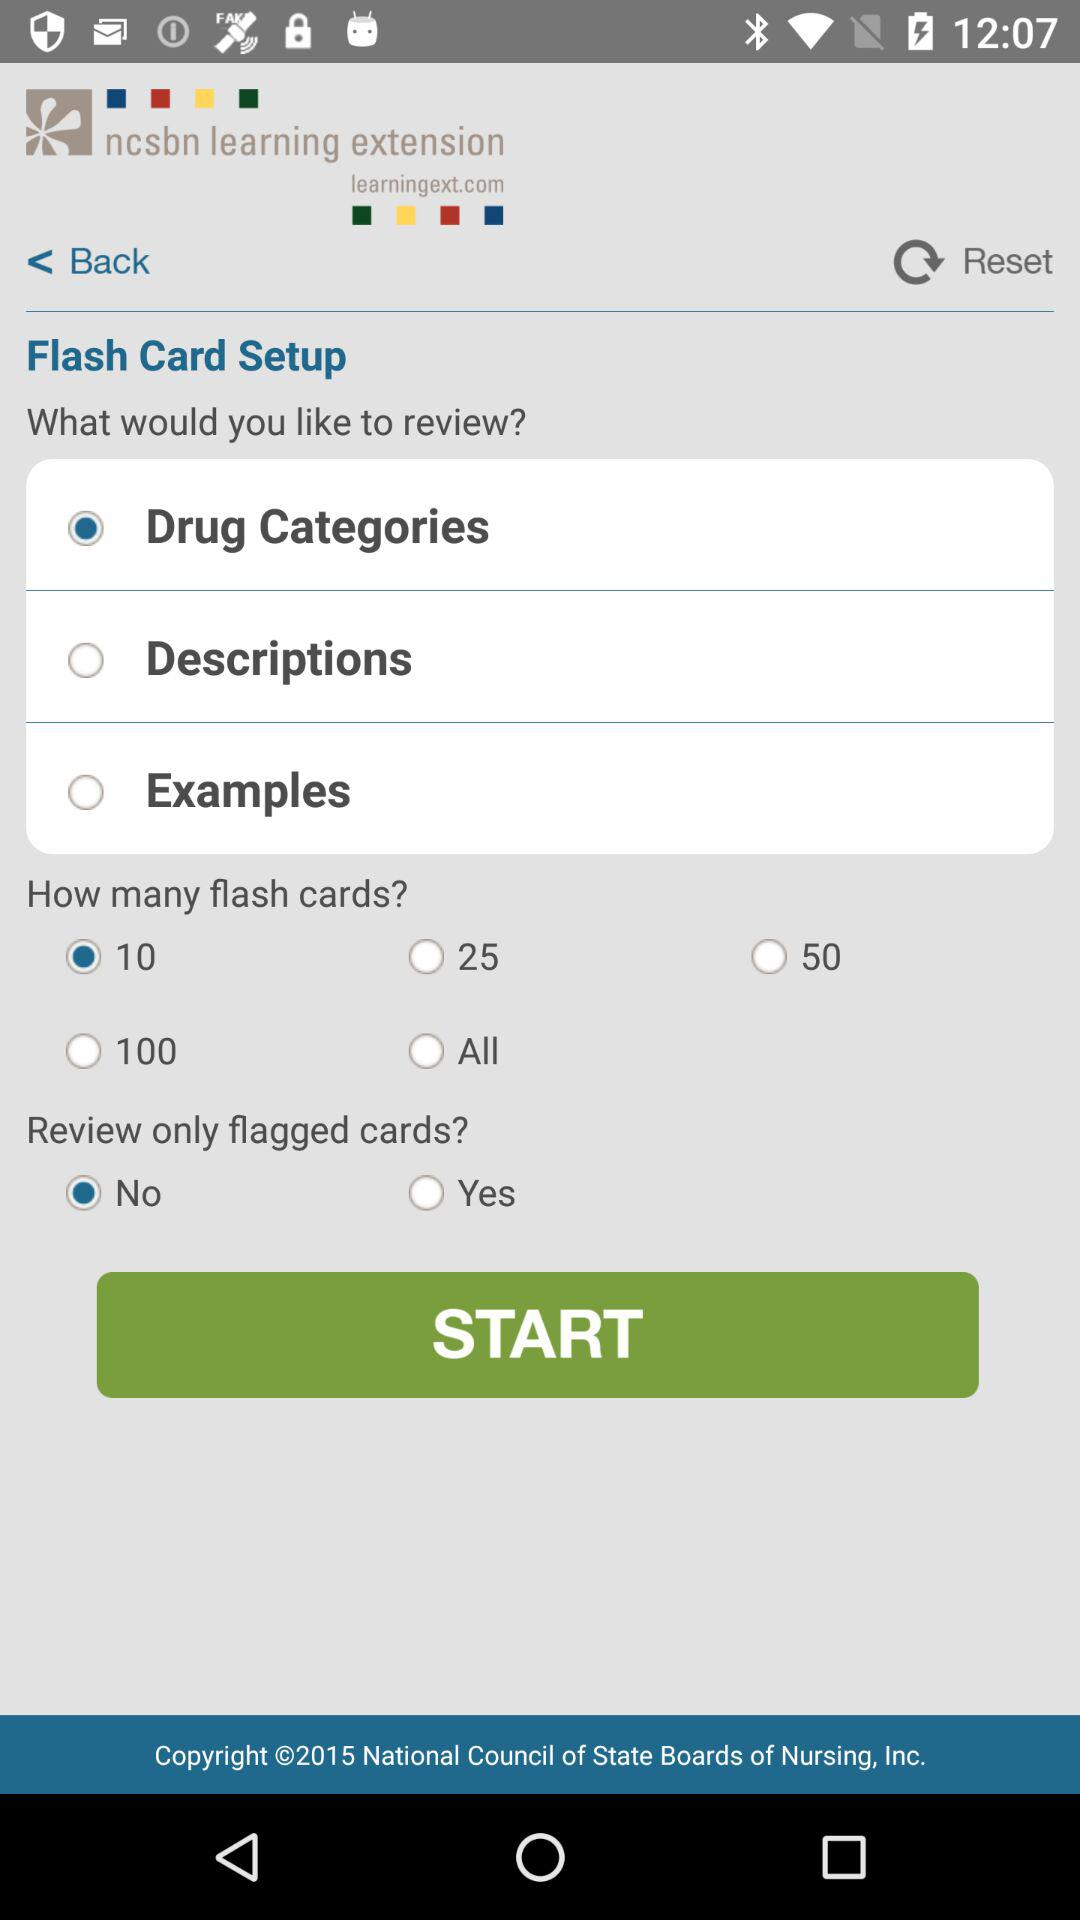What is the number of selected "Flash cards"? The number of selected "Flash cards" is 10. 